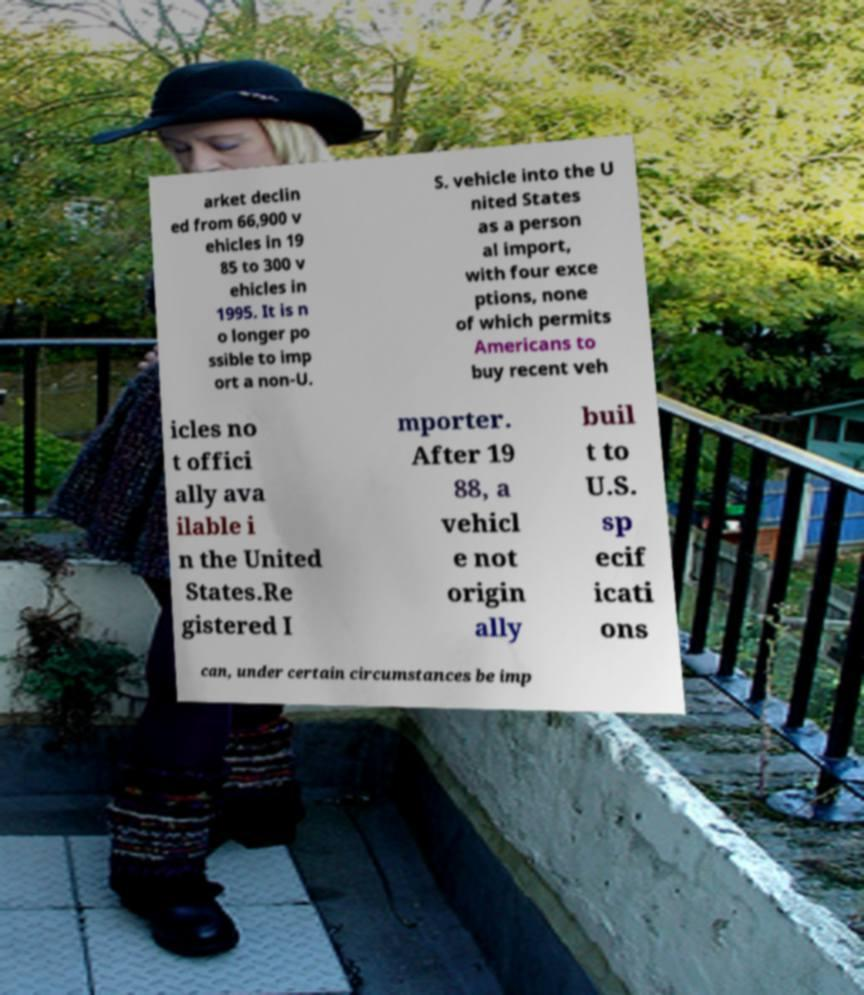For documentation purposes, I need the text within this image transcribed. Could you provide that? arket declin ed from 66,900 v ehicles in 19 85 to 300 v ehicles in 1995. It is n o longer po ssible to imp ort a non-U. S. vehicle into the U nited States as a person al import, with four exce ptions, none of which permits Americans to buy recent veh icles no t offici ally ava ilable i n the United States.Re gistered I mporter. After 19 88, a vehicl e not origin ally buil t to U.S. sp ecif icati ons can, under certain circumstances be imp 